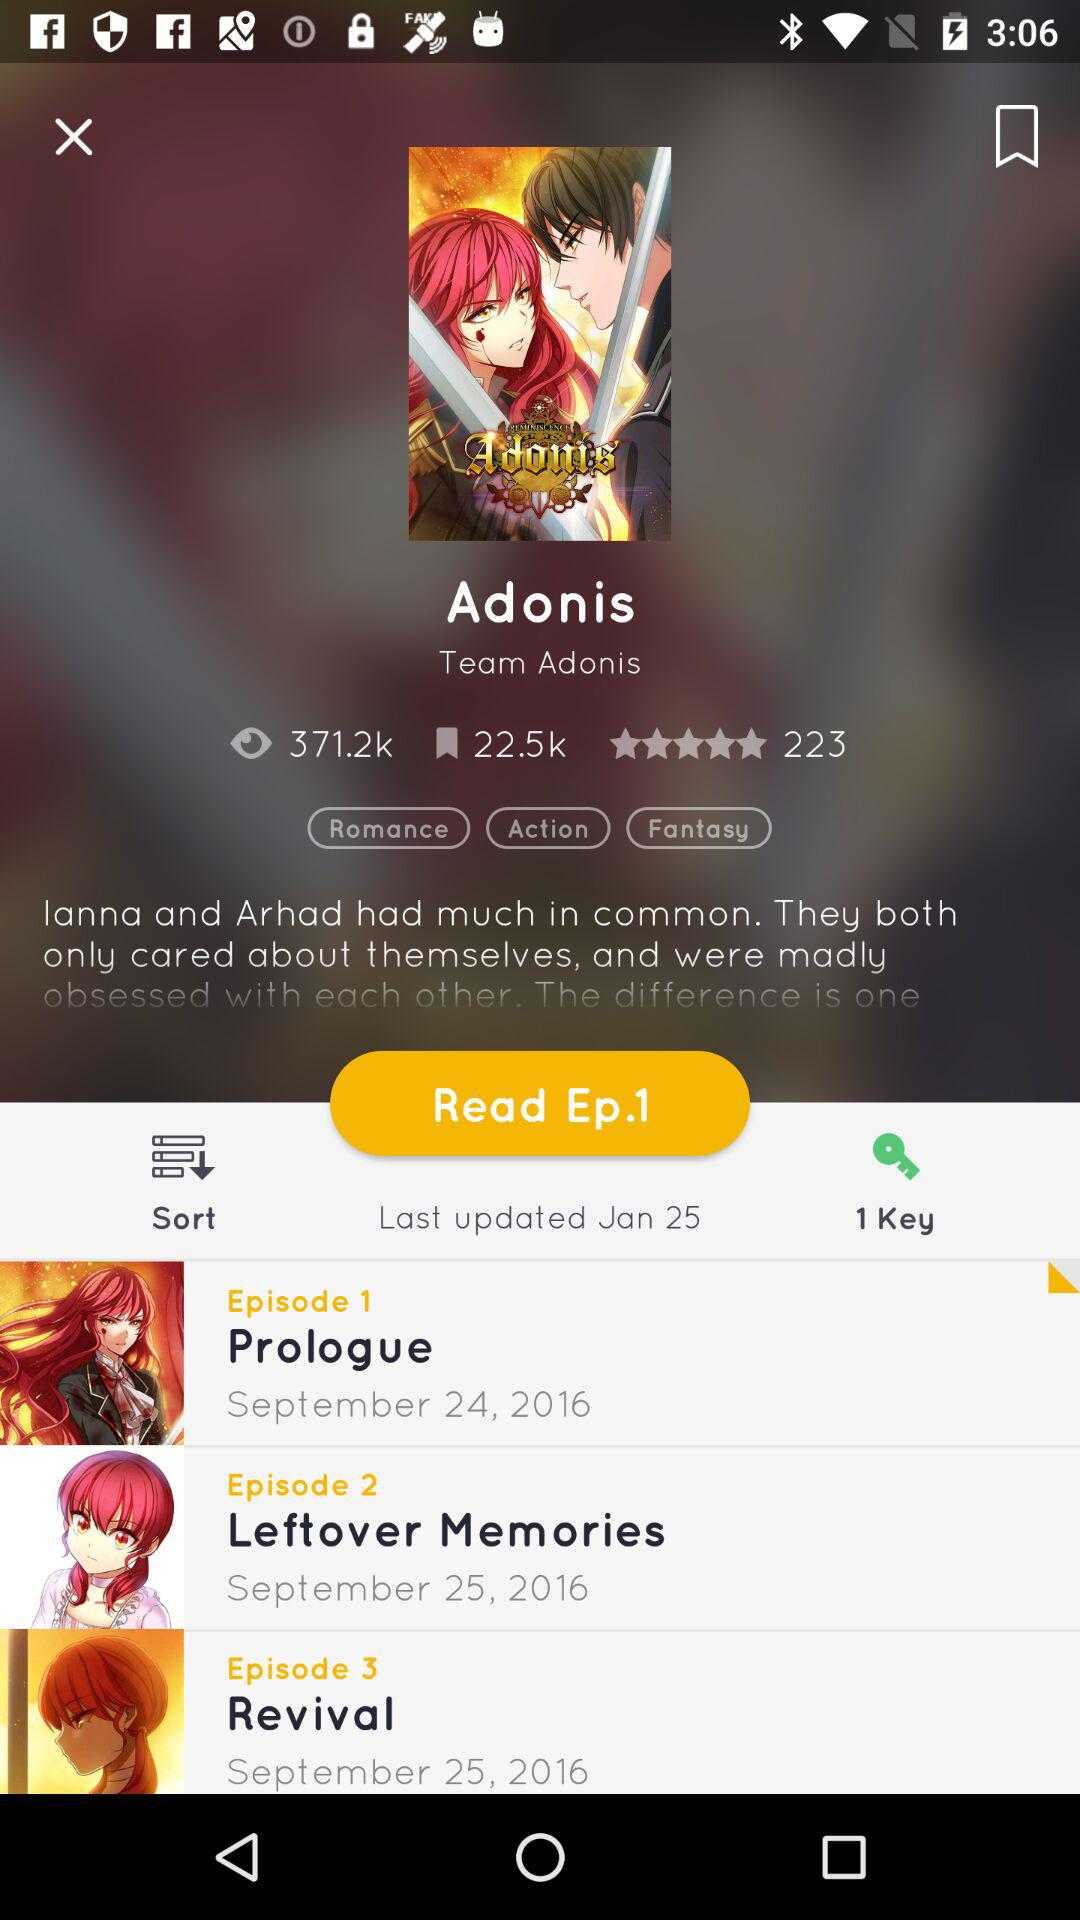How many people have given ratings? Ratings are given by 223 people. 